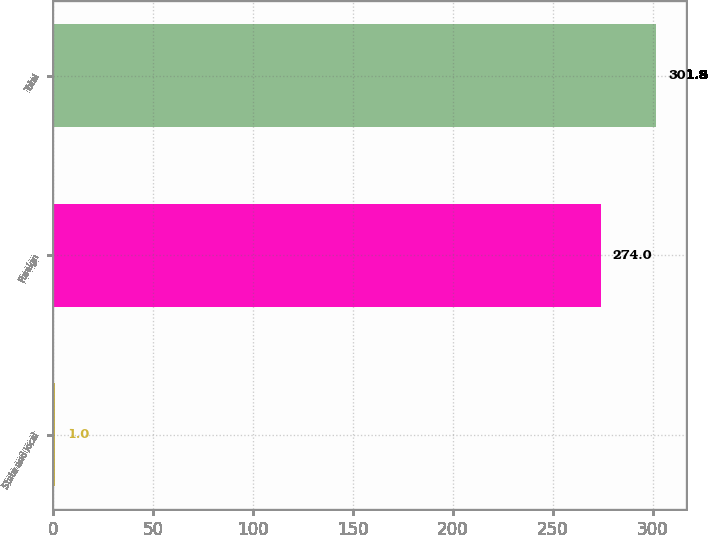<chart> <loc_0><loc_0><loc_500><loc_500><bar_chart><fcel>State and local<fcel>Foreign<fcel>Total<nl><fcel>1<fcel>274<fcel>301.8<nl></chart> 